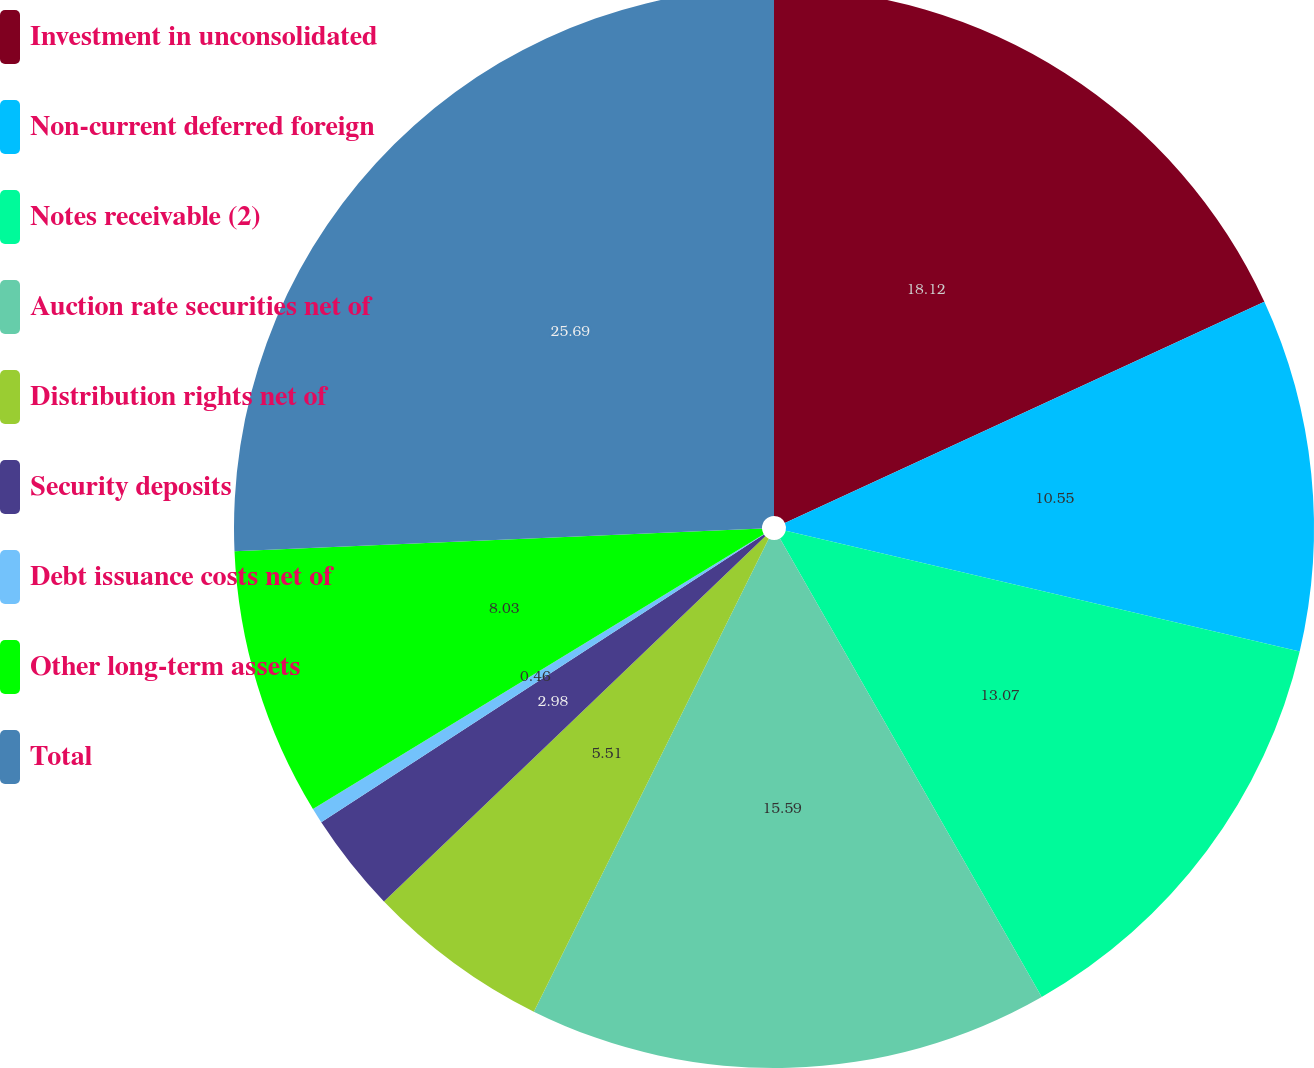Convert chart to OTSL. <chart><loc_0><loc_0><loc_500><loc_500><pie_chart><fcel>Investment in unconsolidated<fcel>Non-current deferred foreign<fcel>Notes receivable (2)<fcel>Auction rate securities net of<fcel>Distribution rights net of<fcel>Security deposits<fcel>Debt issuance costs net of<fcel>Other long-term assets<fcel>Total<nl><fcel>18.12%<fcel>10.55%<fcel>13.07%<fcel>15.59%<fcel>5.51%<fcel>2.98%<fcel>0.46%<fcel>8.03%<fcel>25.68%<nl></chart> 